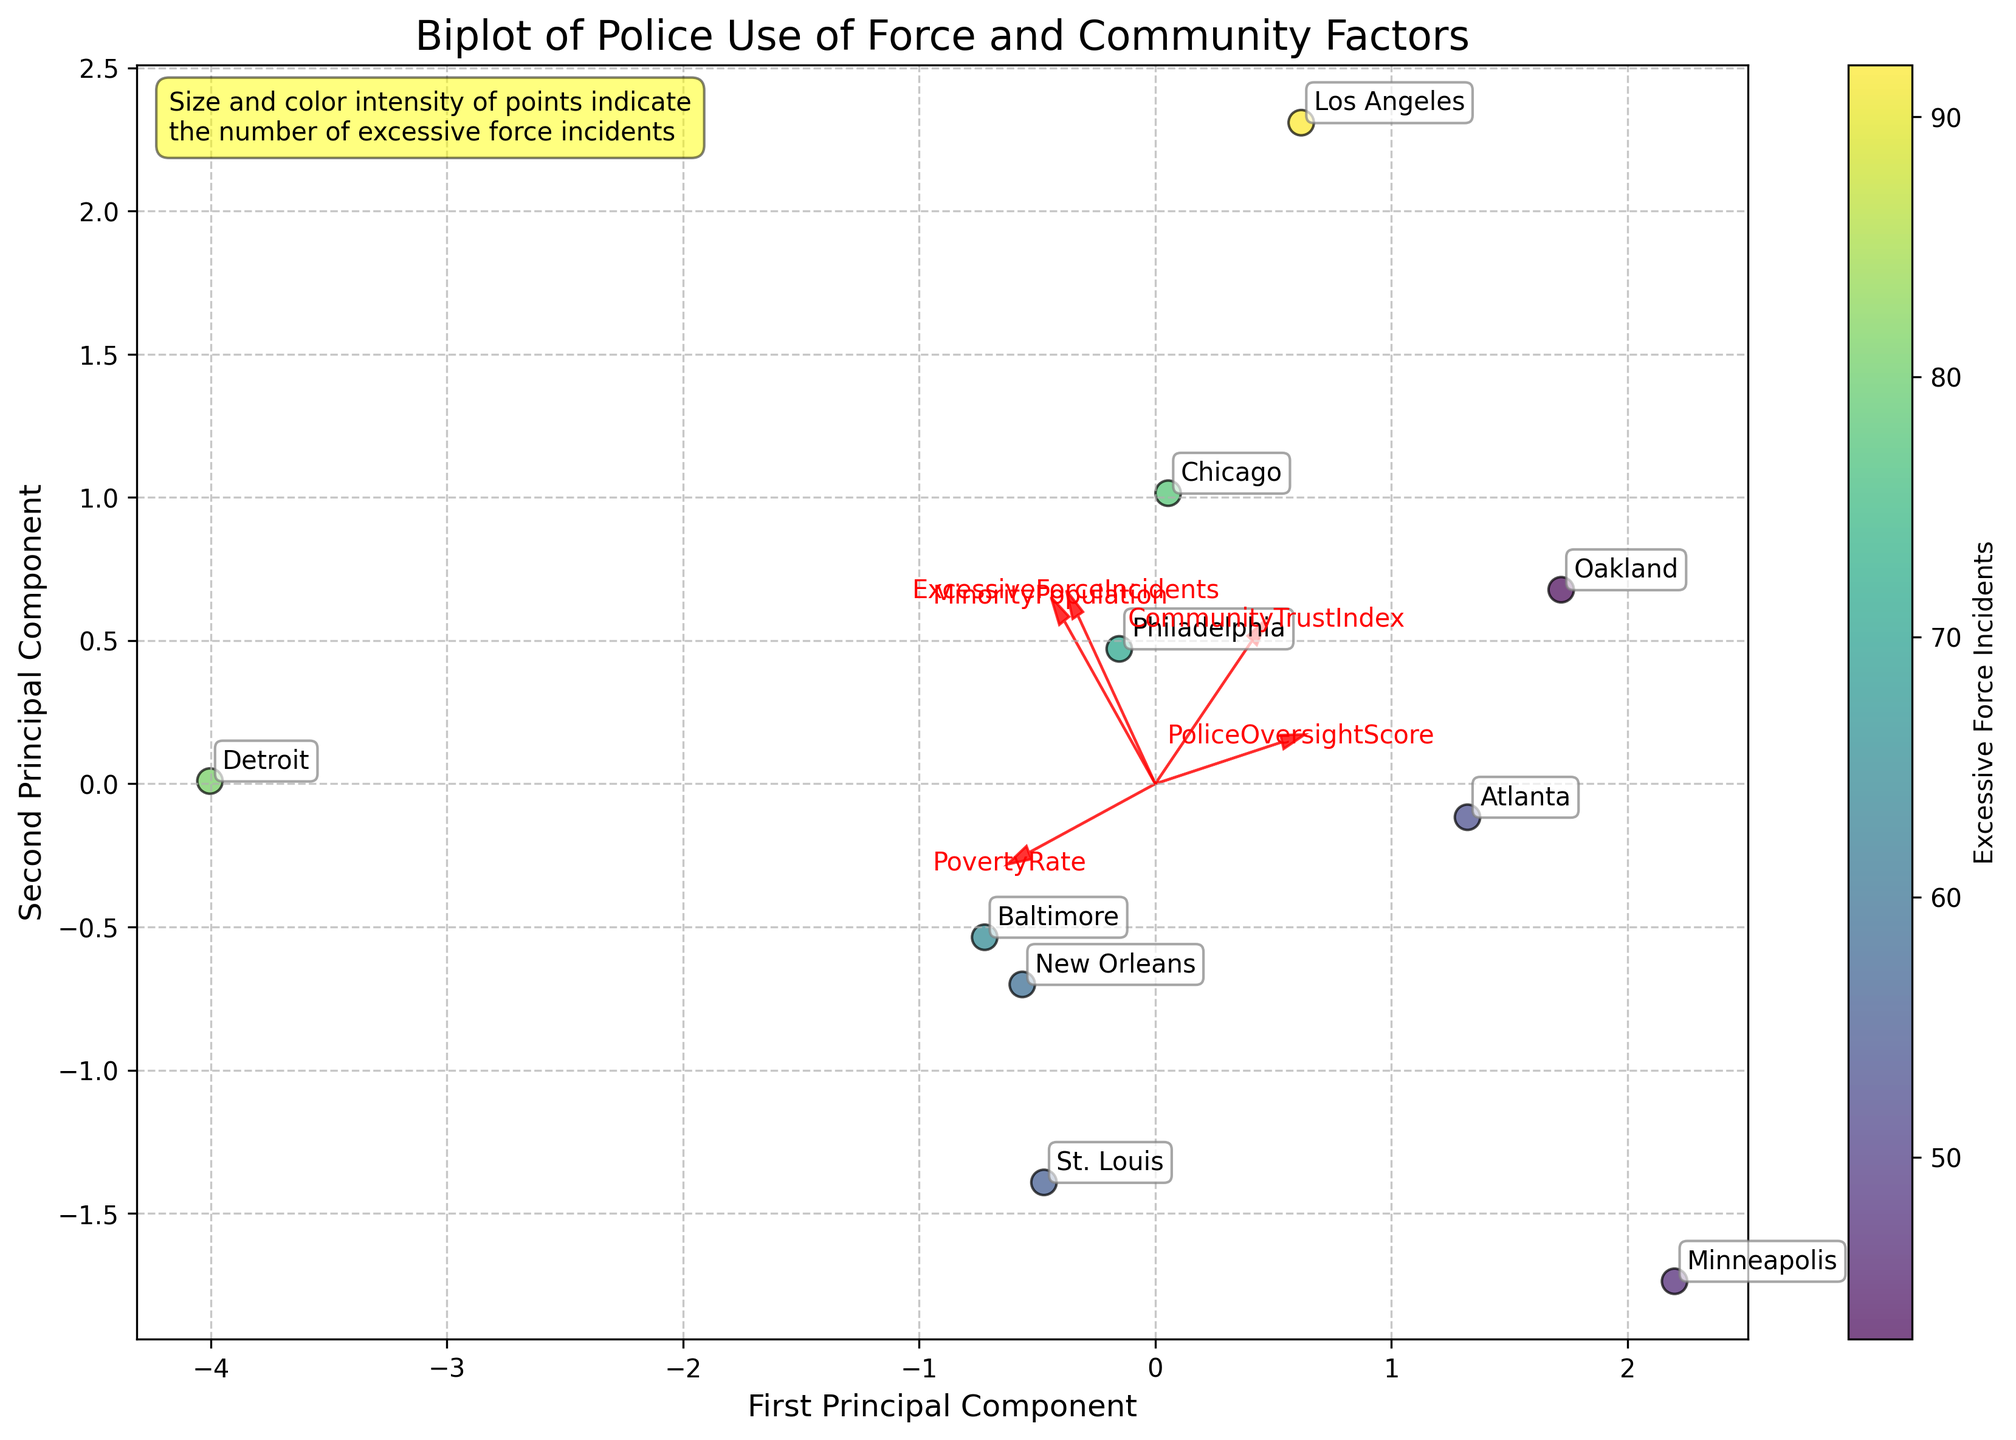What is the title of the plot? The title is typically placed at the top of the plot for easy identification. In this biplot, the title provides a summary of the data being visualized, reading from top to bottom.
Answer: Biplot of Police Use of Force and Community Factors Which city has the highest number of excessive force incidents? The colors and sizes of the data points represent the number of excessive force incidents. The largest and most intensely colored dot indicates the highest number.
Answer: Los Angeles Which axis represents the first principal component? The x-axis label "First Principal Component" indicates it represents the first principal component. Labels are typically positioned horizontally along the axis they describe.
Answer: X-axis In the plot, what does a higher score on the Community Trust Index correlate with? By examining the vectors (arrows) and their directions relative to the Community Trust Index, you can infer correlations. The higher Community Trust Index vector points towards high values on the plot.
Answer: Higher Community Trust Index correlates with higher values on the first principal component Compare the colored data points for Chicago and Baltimore. Which city has a higher number of excessive force incidents? Assessing the size and color intensity of the data points mapped to Chicago and Baltimore will indicate which city experiences a higher number of incidents. The larger and more intensely colored dot corresponds to a higher number.
Answer: Chicago Among the cities, which one has the highest minority population percentage? The direction and length of the 'MinorityPopulation' vector in conjunction with the placement of the cities near its tip provide an indicator of which city has the highest value.
Answer: Detroit How do the arrows (feature vectors) aid in understanding the biplot? Arrows represent the features' loadings on the principal components. Their directions and lengths indicate how much each feature contributes to the principal components and their correlations. Longer arrows mean larger contributions.
Answer: They show the contribution and correlation of each feature with the principal components What do the points closer together in the biplot indicate? The proximity of points on a biplot signifies the similarity of the corresponding cities in terms of their variables. Points closer together exhibit similar patterns across the measured dimensions.
Answer: Similarity in characteristics Between Minneapolis and Oakland, which city has a higher police oversight score? The police oversight score vector points in its increasing direction. By comparing the relative positions of the cities to this vector, you can determine the higher score.
Answer: Minneapolis Where is the color bar and what information does it provide? The color bar is usually placed beside the plot. In this case, it's indicating the number of excessive force incidents corresponding to the color levels from light to dark.
Answer: On the side, indicating excessive force incidents 